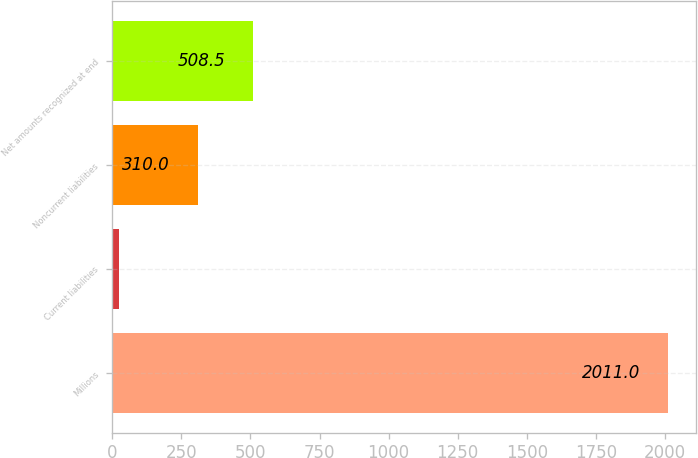<chart> <loc_0><loc_0><loc_500><loc_500><bar_chart><fcel>Millions<fcel>Current liabilities<fcel>Noncurrent liabilities<fcel>Net amounts recognized at end<nl><fcel>2011<fcel>26<fcel>310<fcel>508.5<nl></chart> 